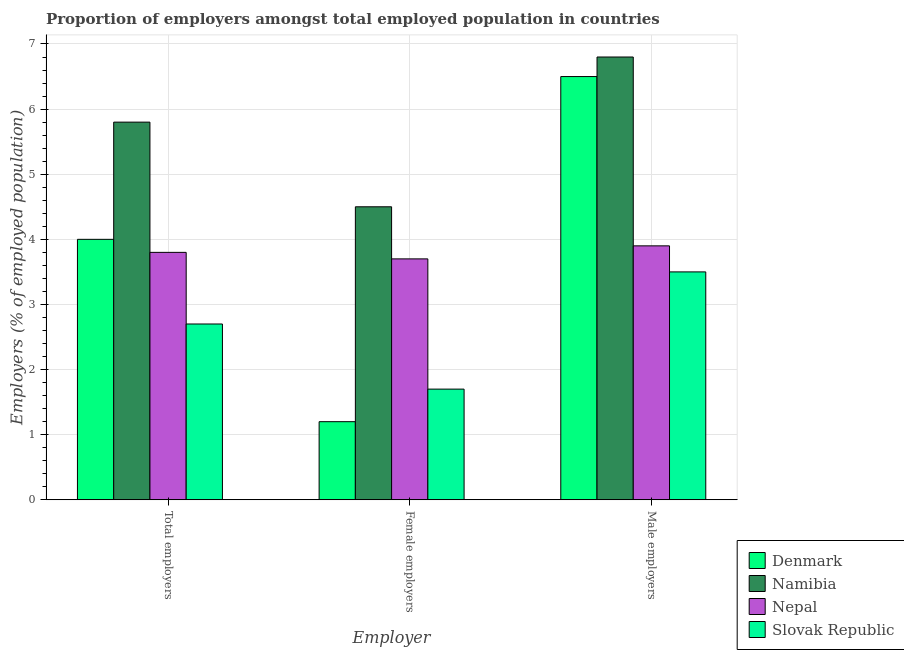Are the number of bars per tick equal to the number of legend labels?
Make the answer very short. Yes. Are the number of bars on each tick of the X-axis equal?
Make the answer very short. Yes. How many bars are there on the 3rd tick from the right?
Provide a short and direct response. 4. What is the label of the 2nd group of bars from the left?
Provide a short and direct response. Female employers. What is the percentage of male employers in Nepal?
Give a very brief answer. 3.9. Across all countries, what is the maximum percentage of total employers?
Provide a short and direct response. 5.8. Across all countries, what is the minimum percentage of total employers?
Give a very brief answer. 2.7. In which country was the percentage of male employers maximum?
Offer a very short reply. Namibia. What is the total percentage of total employers in the graph?
Provide a succinct answer. 16.3. What is the difference between the percentage of total employers in Denmark and that in Nepal?
Your answer should be very brief. 0.2. What is the difference between the percentage of female employers in Namibia and the percentage of total employers in Nepal?
Your answer should be very brief. 0.7. What is the average percentage of female employers per country?
Your response must be concise. 2.78. What is the difference between the percentage of female employers and percentage of male employers in Denmark?
Keep it short and to the point. -5.3. In how many countries, is the percentage of total employers greater than 5.8 %?
Keep it short and to the point. 1. What is the ratio of the percentage of female employers in Namibia to that in Slovak Republic?
Provide a short and direct response. 2.65. Is the difference between the percentage of male employers in Slovak Republic and Nepal greater than the difference between the percentage of total employers in Slovak Republic and Nepal?
Your response must be concise. Yes. What is the difference between the highest and the second highest percentage of female employers?
Provide a succinct answer. 0.8. What is the difference between the highest and the lowest percentage of total employers?
Provide a short and direct response. 3.1. In how many countries, is the percentage of female employers greater than the average percentage of female employers taken over all countries?
Keep it short and to the point. 2. What does the 1st bar from the left in Male employers represents?
Your answer should be compact. Denmark. What does the 2nd bar from the right in Male employers represents?
Make the answer very short. Nepal. Is it the case that in every country, the sum of the percentage of total employers and percentage of female employers is greater than the percentage of male employers?
Give a very brief answer. No. How many bars are there?
Your response must be concise. 12. Are the values on the major ticks of Y-axis written in scientific E-notation?
Your response must be concise. No. Does the graph contain any zero values?
Your answer should be compact. No. Does the graph contain grids?
Offer a terse response. Yes. Where does the legend appear in the graph?
Make the answer very short. Bottom right. How are the legend labels stacked?
Give a very brief answer. Vertical. What is the title of the graph?
Give a very brief answer. Proportion of employers amongst total employed population in countries. What is the label or title of the X-axis?
Your response must be concise. Employer. What is the label or title of the Y-axis?
Give a very brief answer. Employers (% of employed population). What is the Employers (% of employed population) in Denmark in Total employers?
Make the answer very short. 4. What is the Employers (% of employed population) of Namibia in Total employers?
Offer a terse response. 5.8. What is the Employers (% of employed population) of Nepal in Total employers?
Ensure brevity in your answer.  3.8. What is the Employers (% of employed population) in Slovak Republic in Total employers?
Provide a short and direct response. 2.7. What is the Employers (% of employed population) in Denmark in Female employers?
Ensure brevity in your answer.  1.2. What is the Employers (% of employed population) in Namibia in Female employers?
Make the answer very short. 4.5. What is the Employers (% of employed population) of Nepal in Female employers?
Give a very brief answer. 3.7. What is the Employers (% of employed population) of Slovak Republic in Female employers?
Provide a succinct answer. 1.7. What is the Employers (% of employed population) in Denmark in Male employers?
Offer a terse response. 6.5. What is the Employers (% of employed population) in Namibia in Male employers?
Offer a terse response. 6.8. What is the Employers (% of employed population) of Nepal in Male employers?
Ensure brevity in your answer.  3.9. Across all Employer, what is the maximum Employers (% of employed population) in Namibia?
Provide a succinct answer. 6.8. Across all Employer, what is the maximum Employers (% of employed population) of Nepal?
Your answer should be compact. 3.9. Across all Employer, what is the minimum Employers (% of employed population) in Denmark?
Your answer should be very brief. 1.2. Across all Employer, what is the minimum Employers (% of employed population) in Nepal?
Keep it short and to the point. 3.7. Across all Employer, what is the minimum Employers (% of employed population) in Slovak Republic?
Your answer should be very brief. 1.7. What is the total Employers (% of employed population) of Denmark in the graph?
Provide a succinct answer. 11.7. What is the total Employers (% of employed population) in Nepal in the graph?
Make the answer very short. 11.4. What is the difference between the Employers (% of employed population) of Slovak Republic in Total employers and that in Female employers?
Provide a short and direct response. 1. What is the difference between the Employers (% of employed population) in Namibia in Total employers and that in Male employers?
Provide a short and direct response. -1. What is the difference between the Employers (% of employed population) in Nepal in Total employers and that in Male employers?
Give a very brief answer. -0.1. What is the difference between the Employers (% of employed population) of Slovak Republic in Total employers and that in Male employers?
Keep it short and to the point. -0.8. What is the difference between the Employers (% of employed population) of Slovak Republic in Female employers and that in Male employers?
Offer a very short reply. -1.8. What is the difference between the Employers (% of employed population) in Denmark in Total employers and the Employers (% of employed population) in Slovak Republic in Female employers?
Your answer should be very brief. 2.3. What is the difference between the Employers (% of employed population) in Namibia in Total employers and the Employers (% of employed population) in Nepal in Female employers?
Make the answer very short. 2.1. What is the difference between the Employers (% of employed population) of Nepal in Total employers and the Employers (% of employed population) of Slovak Republic in Female employers?
Your answer should be very brief. 2.1. What is the difference between the Employers (% of employed population) of Denmark in Total employers and the Employers (% of employed population) of Nepal in Male employers?
Offer a very short reply. 0.1. What is the difference between the Employers (% of employed population) in Denmark in Total employers and the Employers (% of employed population) in Slovak Republic in Male employers?
Keep it short and to the point. 0.5. What is the difference between the Employers (% of employed population) of Namibia in Total employers and the Employers (% of employed population) of Nepal in Male employers?
Your answer should be very brief. 1.9. What is the difference between the Employers (% of employed population) in Namibia in Total employers and the Employers (% of employed population) in Slovak Republic in Male employers?
Keep it short and to the point. 2.3. What is the difference between the Employers (% of employed population) in Denmark in Female employers and the Employers (% of employed population) in Namibia in Male employers?
Make the answer very short. -5.6. What is the difference between the Employers (% of employed population) in Denmark in Female employers and the Employers (% of employed population) in Slovak Republic in Male employers?
Offer a very short reply. -2.3. What is the average Employers (% of employed population) of Nepal per Employer?
Make the answer very short. 3.8. What is the average Employers (% of employed population) of Slovak Republic per Employer?
Your answer should be compact. 2.63. What is the difference between the Employers (% of employed population) of Denmark and Employers (% of employed population) of Namibia in Total employers?
Ensure brevity in your answer.  -1.8. What is the difference between the Employers (% of employed population) of Denmark and Employers (% of employed population) of Slovak Republic in Total employers?
Offer a very short reply. 1.3. What is the difference between the Employers (% of employed population) of Namibia and Employers (% of employed population) of Nepal in Total employers?
Offer a terse response. 2. What is the difference between the Employers (% of employed population) of Namibia and Employers (% of employed population) of Slovak Republic in Total employers?
Ensure brevity in your answer.  3.1. What is the difference between the Employers (% of employed population) of Nepal and Employers (% of employed population) of Slovak Republic in Total employers?
Offer a very short reply. 1.1. What is the difference between the Employers (% of employed population) of Denmark and Employers (% of employed population) of Namibia in Female employers?
Provide a succinct answer. -3.3. What is the difference between the Employers (% of employed population) in Denmark and Employers (% of employed population) in Slovak Republic in Female employers?
Offer a terse response. -0.5. What is the difference between the Employers (% of employed population) of Namibia and Employers (% of employed population) of Nepal in Female employers?
Make the answer very short. 0.8. What is the difference between the Employers (% of employed population) of Denmark and Employers (% of employed population) of Namibia in Male employers?
Provide a short and direct response. -0.3. What is the difference between the Employers (% of employed population) in Nepal and Employers (% of employed population) in Slovak Republic in Male employers?
Keep it short and to the point. 0.4. What is the ratio of the Employers (% of employed population) of Namibia in Total employers to that in Female employers?
Your answer should be compact. 1.29. What is the ratio of the Employers (% of employed population) of Slovak Republic in Total employers to that in Female employers?
Your response must be concise. 1.59. What is the ratio of the Employers (% of employed population) in Denmark in Total employers to that in Male employers?
Offer a very short reply. 0.62. What is the ratio of the Employers (% of employed population) in Namibia in Total employers to that in Male employers?
Give a very brief answer. 0.85. What is the ratio of the Employers (% of employed population) in Nepal in Total employers to that in Male employers?
Your answer should be very brief. 0.97. What is the ratio of the Employers (% of employed population) in Slovak Republic in Total employers to that in Male employers?
Your answer should be very brief. 0.77. What is the ratio of the Employers (% of employed population) of Denmark in Female employers to that in Male employers?
Offer a terse response. 0.18. What is the ratio of the Employers (% of employed population) in Namibia in Female employers to that in Male employers?
Your answer should be compact. 0.66. What is the ratio of the Employers (% of employed population) in Nepal in Female employers to that in Male employers?
Your answer should be very brief. 0.95. What is the ratio of the Employers (% of employed population) in Slovak Republic in Female employers to that in Male employers?
Ensure brevity in your answer.  0.49. What is the difference between the highest and the second highest Employers (% of employed population) of Denmark?
Offer a terse response. 2.5. What is the difference between the highest and the second highest Employers (% of employed population) in Namibia?
Give a very brief answer. 1. What is the difference between the highest and the second highest Employers (% of employed population) of Slovak Republic?
Offer a terse response. 0.8. What is the difference between the highest and the lowest Employers (% of employed population) of Nepal?
Make the answer very short. 0.2. What is the difference between the highest and the lowest Employers (% of employed population) of Slovak Republic?
Provide a succinct answer. 1.8. 